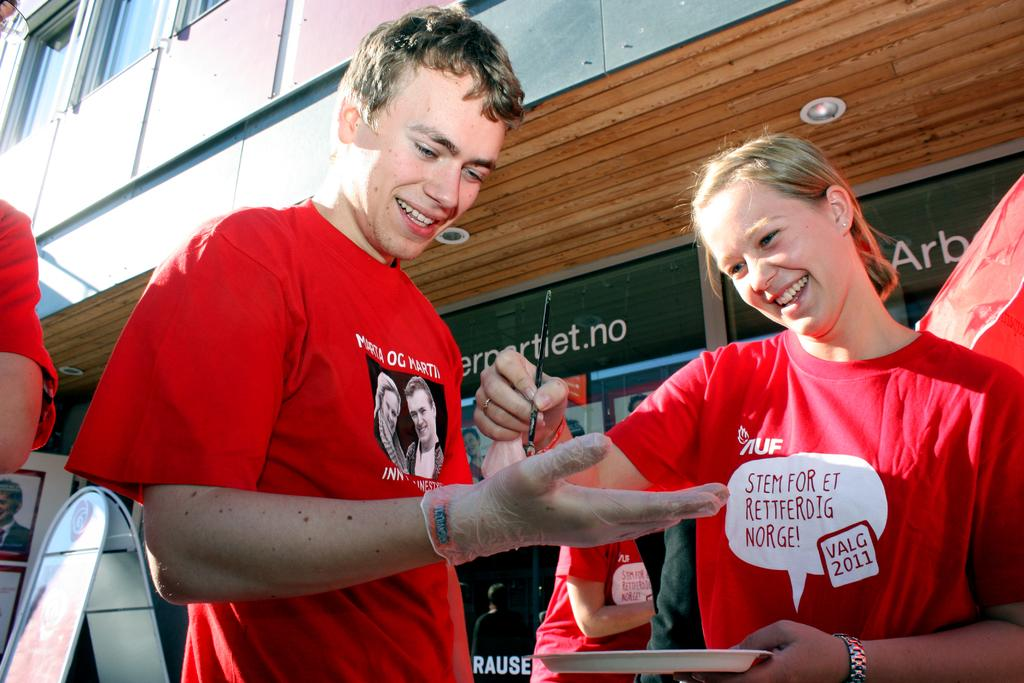How many people are in the image? There is a group of people standing in the image. What is one person holding in the image? There is a person holding a paint brush in the image. What object can be seen on a surface in the image? There is a plate in the image. What can be seen in the background of the image? There are boards and a building in the background of the image. How many tomatoes are on the plate in the image? There is no plate with tomatoes present in the image; the plate is empty. What type of tree can be seen in the image? There is no tree present in the image. 